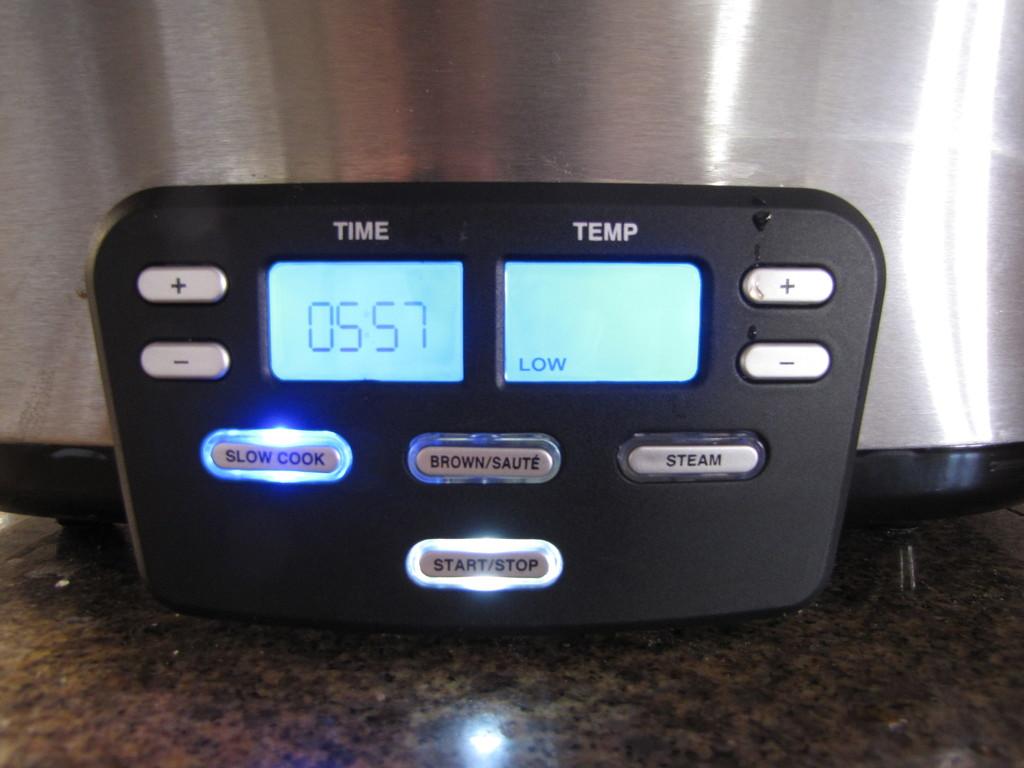What is the temp?
Ensure brevity in your answer.  Low. 